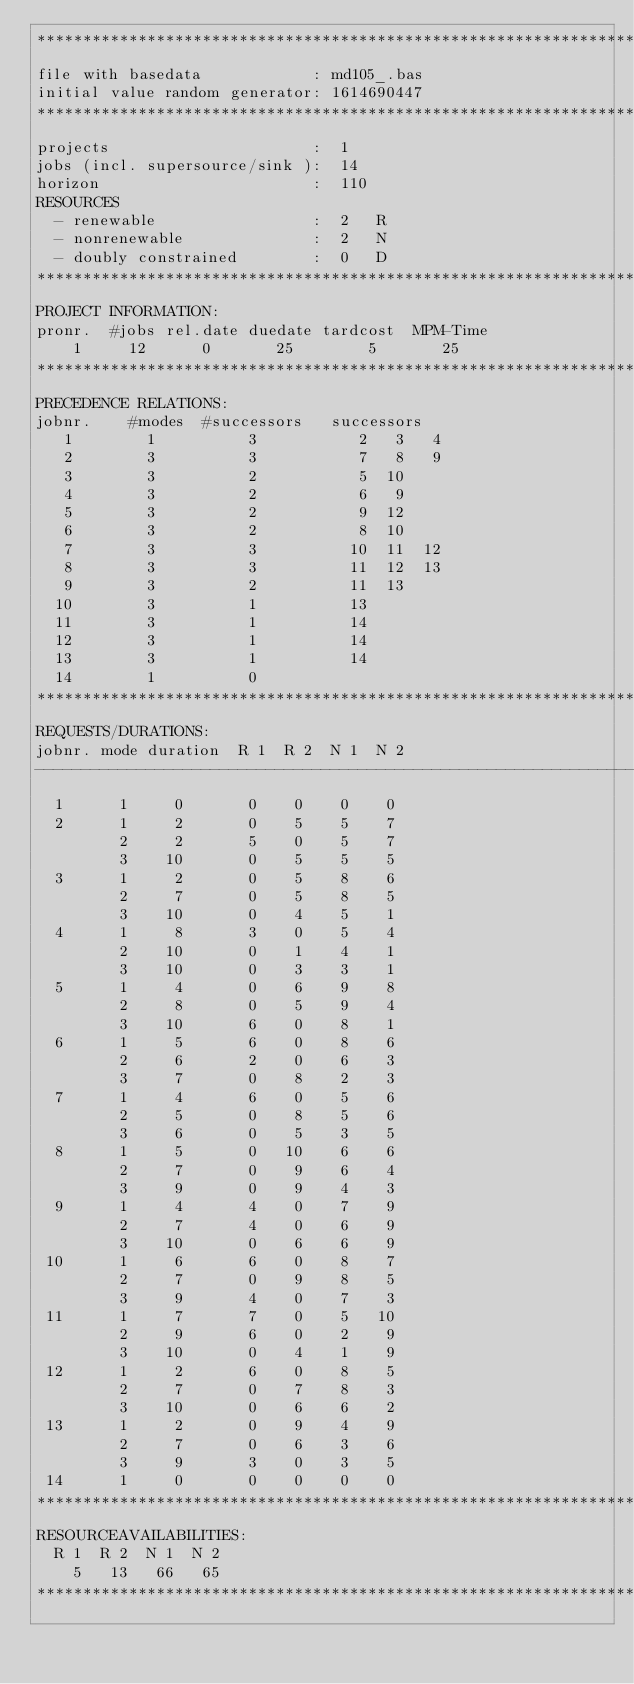Convert code to text. <code><loc_0><loc_0><loc_500><loc_500><_ObjectiveC_>************************************************************************
file with basedata            : md105_.bas
initial value random generator: 1614690447
************************************************************************
projects                      :  1
jobs (incl. supersource/sink ):  14
horizon                       :  110
RESOURCES
  - renewable                 :  2   R
  - nonrenewable              :  2   N
  - doubly constrained        :  0   D
************************************************************************
PROJECT INFORMATION:
pronr.  #jobs rel.date duedate tardcost  MPM-Time
    1     12      0       25        5       25
************************************************************************
PRECEDENCE RELATIONS:
jobnr.    #modes  #successors   successors
   1        1          3           2   3   4
   2        3          3           7   8   9
   3        3          2           5  10
   4        3          2           6   9
   5        3          2           9  12
   6        3          2           8  10
   7        3          3          10  11  12
   8        3          3          11  12  13
   9        3          2          11  13
  10        3          1          13
  11        3          1          14
  12        3          1          14
  13        3          1          14
  14        1          0        
************************************************************************
REQUESTS/DURATIONS:
jobnr. mode duration  R 1  R 2  N 1  N 2
------------------------------------------------------------------------
  1      1     0       0    0    0    0
  2      1     2       0    5    5    7
         2     2       5    0    5    7
         3    10       0    5    5    5
  3      1     2       0    5    8    6
         2     7       0    5    8    5
         3    10       0    4    5    1
  4      1     8       3    0    5    4
         2    10       0    1    4    1
         3    10       0    3    3    1
  5      1     4       0    6    9    8
         2     8       0    5    9    4
         3    10       6    0    8    1
  6      1     5       6    0    8    6
         2     6       2    0    6    3
         3     7       0    8    2    3
  7      1     4       6    0    5    6
         2     5       0    8    5    6
         3     6       0    5    3    5
  8      1     5       0   10    6    6
         2     7       0    9    6    4
         3     9       0    9    4    3
  9      1     4       4    0    7    9
         2     7       4    0    6    9
         3    10       0    6    6    9
 10      1     6       6    0    8    7
         2     7       0    9    8    5
         3     9       4    0    7    3
 11      1     7       7    0    5   10
         2     9       6    0    2    9
         3    10       0    4    1    9
 12      1     2       6    0    8    5
         2     7       0    7    8    3
         3    10       0    6    6    2
 13      1     2       0    9    4    9
         2     7       0    6    3    6
         3     9       3    0    3    5
 14      1     0       0    0    0    0
************************************************************************
RESOURCEAVAILABILITIES:
  R 1  R 2  N 1  N 2
    5   13   66   65
************************************************************************
</code> 